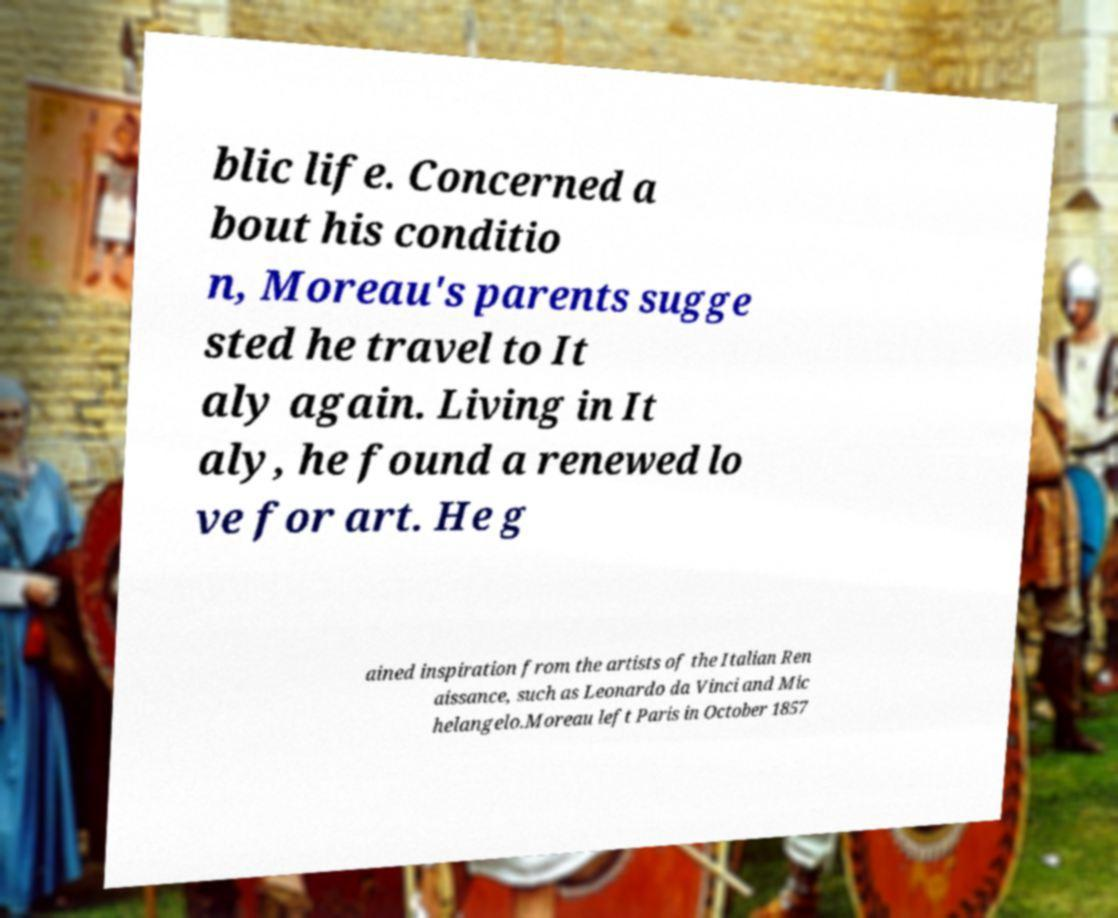There's text embedded in this image that I need extracted. Can you transcribe it verbatim? blic life. Concerned a bout his conditio n, Moreau's parents sugge sted he travel to It aly again. Living in It aly, he found a renewed lo ve for art. He g ained inspiration from the artists of the Italian Ren aissance, such as Leonardo da Vinci and Mic helangelo.Moreau left Paris in October 1857 